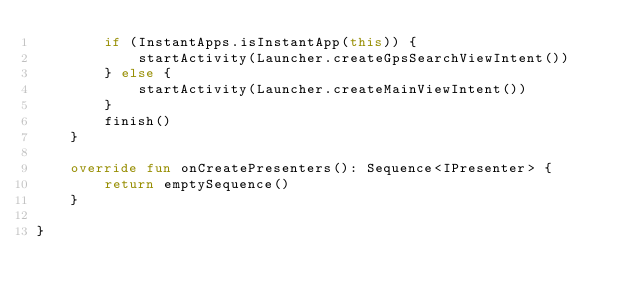<code> <loc_0><loc_0><loc_500><loc_500><_Kotlin_>        if (InstantApps.isInstantApp(this)) {
            startActivity(Launcher.createGpsSearchViewIntent())
        } else {
            startActivity(Launcher.createMainViewIntent())
        }
        finish()
    }

    override fun onCreatePresenters(): Sequence<IPresenter> {
        return emptySequence()
    }

}</code> 